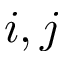Convert formula to latex. <formula><loc_0><loc_0><loc_500><loc_500>i , j</formula> 